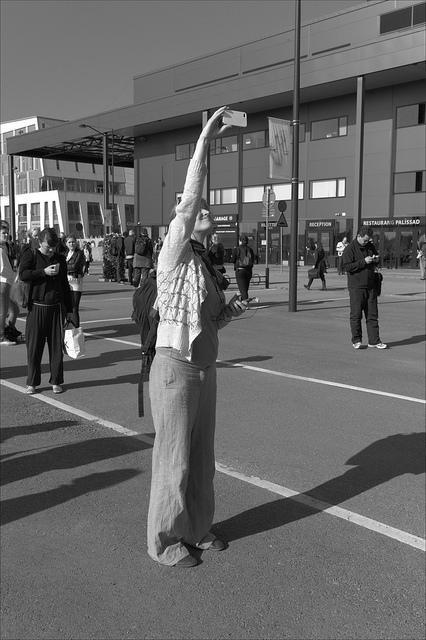Why is the woman holding her phone above her head?
Answer the question by selecting the correct answer among the 4 following choices.
Options: Playing game, checking signal, watching video, taking photo. Taking photo. 